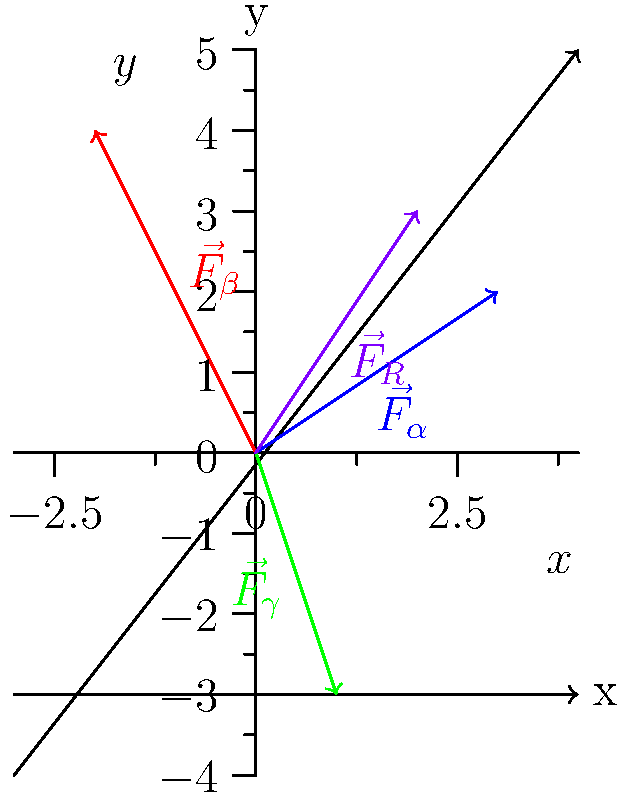In a nuclear physics experiment, three types of radiation are detected: alpha ($\vec{F}_\alpha$), beta ($\vec{F}_\beta$), and gamma ($\vec{F}_\gamma$). The forces exerted by these radiations are represented by vectors in the xy-plane as shown in the diagram. Alpha radiation exerts a force of 3 units in the x-direction and 2 units in the y-direction, beta radiation exerts a force of -2 units in the x-direction and 4 units in the y-direction, and gamma radiation exerts a force of 1 unit in the x-direction and -3 units in the y-direction. Calculate the magnitude of the resultant force ($\vec{F}_R$) to the nearest tenth. To find the magnitude of the resultant force, we need to follow these steps:

1) First, we need to find the x and y components of the resultant force by adding the corresponding components of each vector:

   $F_{Rx} = F_{\alpha x} + F_{\beta x} + F_{\gamma x} = 3 + (-2) + 1 = 2$
   $F_{Ry} = F_{\alpha y} + F_{\beta y} + F_{\gamma y} = 2 + 4 + (-3) = 3$

2) Now we have the components of the resultant force vector: $\vec{F}_R = (2, 3)$

3) To find the magnitude of this vector, we use the Pythagorean theorem:

   $|\vec{F}_R| = \sqrt{F_{Rx}^2 + F_{Ry}^2}$

4) Substituting the values:

   $|\vec{F}_R| = \sqrt{2^2 + 3^2} = \sqrt{4 + 9} = \sqrt{13}$

5) Calculate this value:

   $\sqrt{13} \approx 3.6055$

6) Rounding to the nearest tenth:

   $|\vec{F}_R| \approx 3.6$ units

Therefore, the magnitude of the resultant force is approximately 3.6 units.
Answer: 3.6 units 